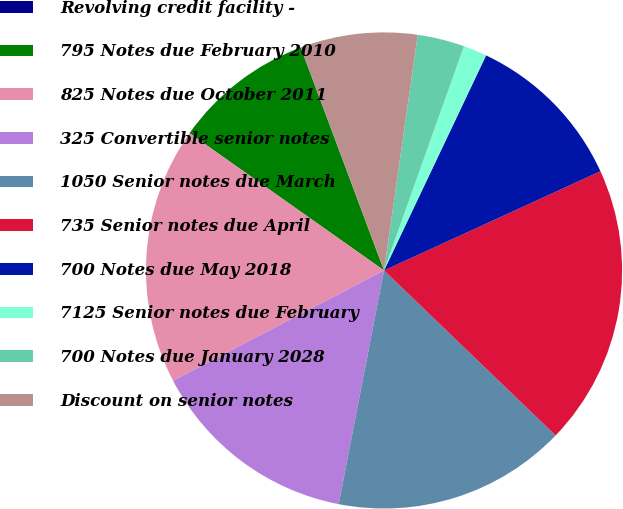Convert chart to OTSL. <chart><loc_0><loc_0><loc_500><loc_500><pie_chart><fcel>Revolving credit facility -<fcel>795 Notes due February 2010<fcel>825 Notes due October 2011<fcel>325 Convertible senior notes<fcel>1050 Senior notes due March<fcel>735 Senior notes due April<fcel>700 Notes due May 2018<fcel>7125 Senior notes due February<fcel>700 Notes due January 2028<fcel>Discount on senior notes<nl><fcel>0.02%<fcel>9.52%<fcel>17.45%<fcel>14.28%<fcel>15.86%<fcel>19.03%<fcel>11.11%<fcel>1.6%<fcel>3.19%<fcel>7.94%<nl></chart> 